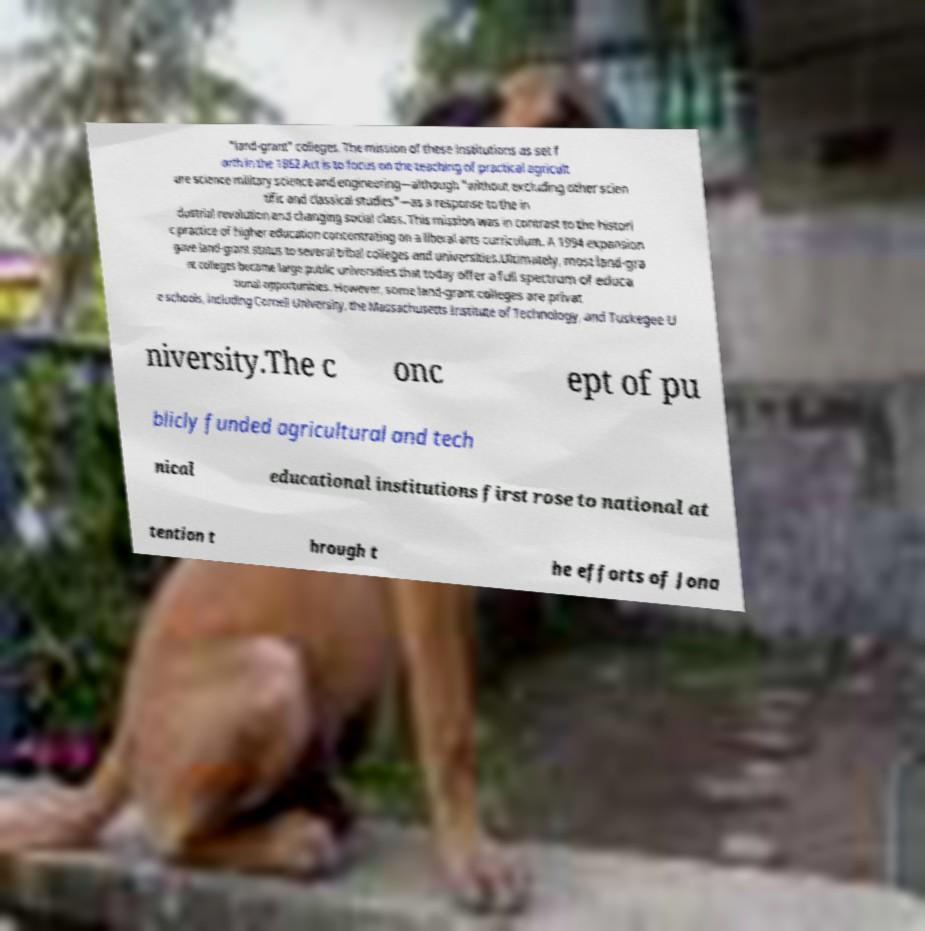Please read and relay the text visible in this image. What does it say? "land-grant" colleges. The mission of these institutions as set f orth in the 1862 Act is to focus on the teaching of practical agricult ure science military science and engineering—although "without excluding other scien tific and classical studies"—as a response to the in dustrial revolution and changing social class. This mission was in contrast to the histori c practice of higher education concentrating on a liberal arts curriculum. A 1994 expansion gave land-grant status to several tribal colleges and universities.Ultimately, most land-gra nt colleges became large public universities that today offer a full spectrum of educa tional opportunities. However, some land-grant colleges are privat e schools, including Cornell University, the Massachusetts Institute of Technology, and Tuskegee U niversity.The c onc ept of pu blicly funded agricultural and tech nical educational institutions first rose to national at tention t hrough t he efforts of Jona 